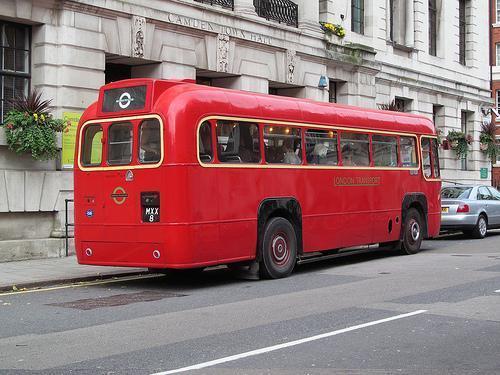How many windows on this bus face toward the traffic behind it?
Give a very brief answer. 3. 